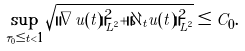Convert formula to latex. <formula><loc_0><loc_0><loc_500><loc_500>\sup _ { \tau _ { 0 } \leq t < 1 } \sqrt { \| \nabla u ( t ) \| _ { L ^ { 2 } } ^ { 2 } + \| \partial _ { t } u ( t ) \| _ { L ^ { 2 } } ^ { 2 } } \leq C _ { 0 } .</formula> 